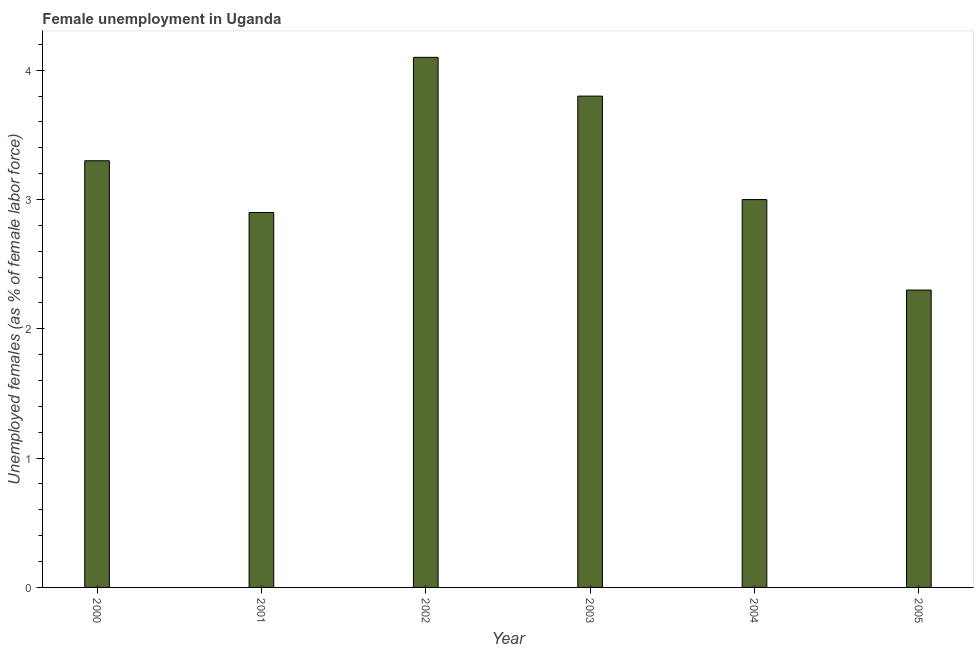Does the graph contain any zero values?
Ensure brevity in your answer.  No. Does the graph contain grids?
Your answer should be very brief. No. What is the title of the graph?
Your answer should be compact. Female unemployment in Uganda. What is the label or title of the Y-axis?
Offer a very short reply. Unemployed females (as % of female labor force). What is the unemployed females population in 2005?
Ensure brevity in your answer.  2.3. Across all years, what is the maximum unemployed females population?
Your answer should be very brief. 4.1. Across all years, what is the minimum unemployed females population?
Make the answer very short. 2.3. In which year was the unemployed females population maximum?
Provide a succinct answer. 2002. What is the sum of the unemployed females population?
Give a very brief answer. 19.4. What is the average unemployed females population per year?
Provide a succinct answer. 3.23. What is the median unemployed females population?
Your response must be concise. 3.15. What is the ratio of the unemployed females population in 2002 to that in 2003?
Your answer should be very brief. 1.08. Is the difference between the unemployed females population in 2000 and 2001 greater than the difference between any two years?
Offer a terse response. No. What is the difference between the highest and the second highest unemployed females population?
Your answer should be compact. 0.3. Is the sum of the unemployed females population in 2000 and 2004 greater than the maximum unemployed females population across all years?
Your answer should be compact. Yes. What is the difference between the highest and the lowest unemployed females population?
Your answer should be very brief. 1.8. How many years are there in the graph?
Keep it short and to the point. 6. What is the difference between two consecutive major ticks on the Y-axis?
Ensure brevity in your answer.  1. What is the Unemployed females (as % of female labor force) of 2000?
Make the answer very short. 3.3. What is the Unemployed females (as % of female labor force) of 2001?
Keep it short and to the point. 2.9. What is the Unemployed females (as % of female labor force) of 2002?
Give a very brief answer. 4.1. What is the Unemployed females (as % of female labor force) in 2003?
Keep it short and to the point. 3.8. What is the Unemployed females (as % of female labor force) in 2004?
Ensure brevity in your answer.  3. What is the Unemployed females (as % of female labor force) of 2005?
Give a very brief answer. 2.3. What is the difference between the Unemployed females (as % of female labor force) in 2000 and 2001?
Your answer should be compact. 0.4. What is the difference between the Unemployed females (as % of female labor force) in 2001 and 2003?
Give a very brief answer. -0.9. What is the difference between the Unemployed females (as % of female labor force) in 2001 and 2005?
Keep it short and to the point. 0.6. What is the difference between the Unemployed females (as % of female labor force) in 2002 and 2003?
Your answer should be very brief. 0.3. What is the difference between the Unemployed females (as % of female labor force) in 2002 and 2004?
Offer a very short reply. 1.1. What is the difference between the Unemployed females (as % of female labor force) in 2002 and 2005?
Provide a short and direct response. 1.8. What is the difference between the Unemployed females (as % of female labor force) in 2003 and 2004?
Your answer should be compact. 0.8. What is the difference between the Unemployed females (as % of female labor force) in 2003 and 2005?
Your answer should be compact. 1.5. What is the ratio of the Unemployed females (as % of female labor force) in 2000 to that in 2001?
Your response must be concise. 1.14. What is the ratio of the Unemployed females (as % of female labor force) in 2000 to that in 2002?
Offer a terse response. 0.81. What is the ratio of the Unemployed females (as % of female labor force) in 2000 to that in 2003?
Offer a terse response. 0.87. What is the ratio of the Unemployed females (as % of female labor force) in 2000 to that in 2005?
Keep it short and to the point. 1.44. What is the ratio of the Unemployed females (as % of female labor force) in 2001 to that in 2002?
Provide a succinct answer. 0.71. What is the ratio of the Unemployed females (as % of female labor force) in 2001 to that in 2003?
Offer a very short reply. 0.76. What is the ratio of the Unemployed females (as % of female labor force) in 2001 to that in 2005?
Provide a short and direct response. 1.26. What is the ratio of the Unemployed females (as % of female labor force) in 2002 to that in 2003?
Give a very brief answer. 1.08. What is the ratio of the Unemployed females (as % of female labor force) in 2002 to that in 2004?
Provide a short and direct response. 1.37. What is the ratio of the Unemployed females (as % of female labor force) in 2002 to that in 2005?
Your answer should be very brief. 1.78. What is the ratio of the Unemployed females (as % of female labor force) in 2003 to that in 2004?
Offer a very short reply. 1.27. What is the ratio of the Unemployed females (as % of female labor force) in 2003 to that in 2005?
Make the answer very short. 1.65. What is the ratio of the Unemployed females (as % of female labor force) in 2004 to that in 2005?
Keep it short and to the point. 1.3. 